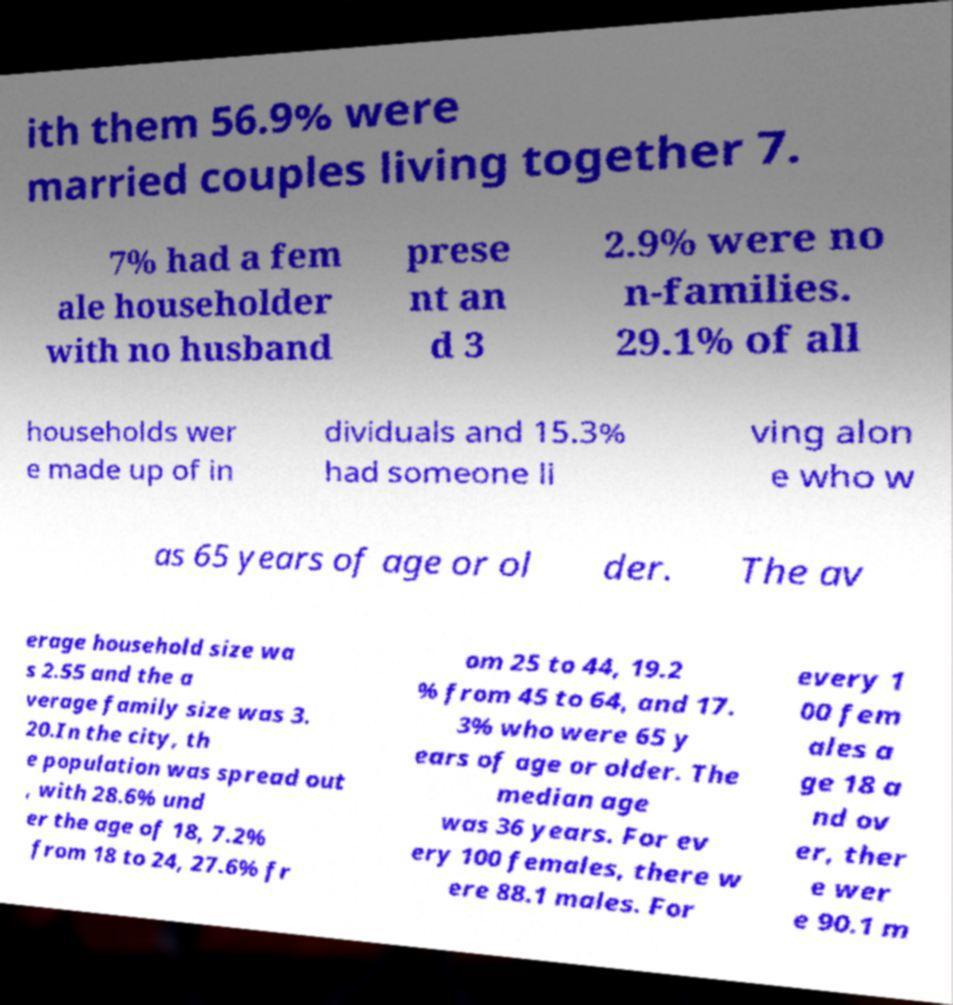Could you extract and type out the text from this image? ith them 56.9% were married couples living together 7. 7% had a fem ale householder with no husband prese nt an d 3 2.9% were no n-families. 29.1% of all households wer e made up of in dividuals and 15.3% had someone li ving alon e who w as 65 years of age or ol der. The av erage household size wa s 2.55 and the a verage family size was 3. 20.In the city, th e population was spread out , with 28.6% und er the age of 18, 7.2% from 18 to 24, 27.6% fr om 25 to 44, 19.2 % from 45 to 64, and 17. 3% who were 65 y ears of age or older. The median age was 36 years. For ev ery 100 females, there w ere 88.1 males. For every 1 00 fem ales a ge 18 a nd ov er, ther e wer e 90.1 m 